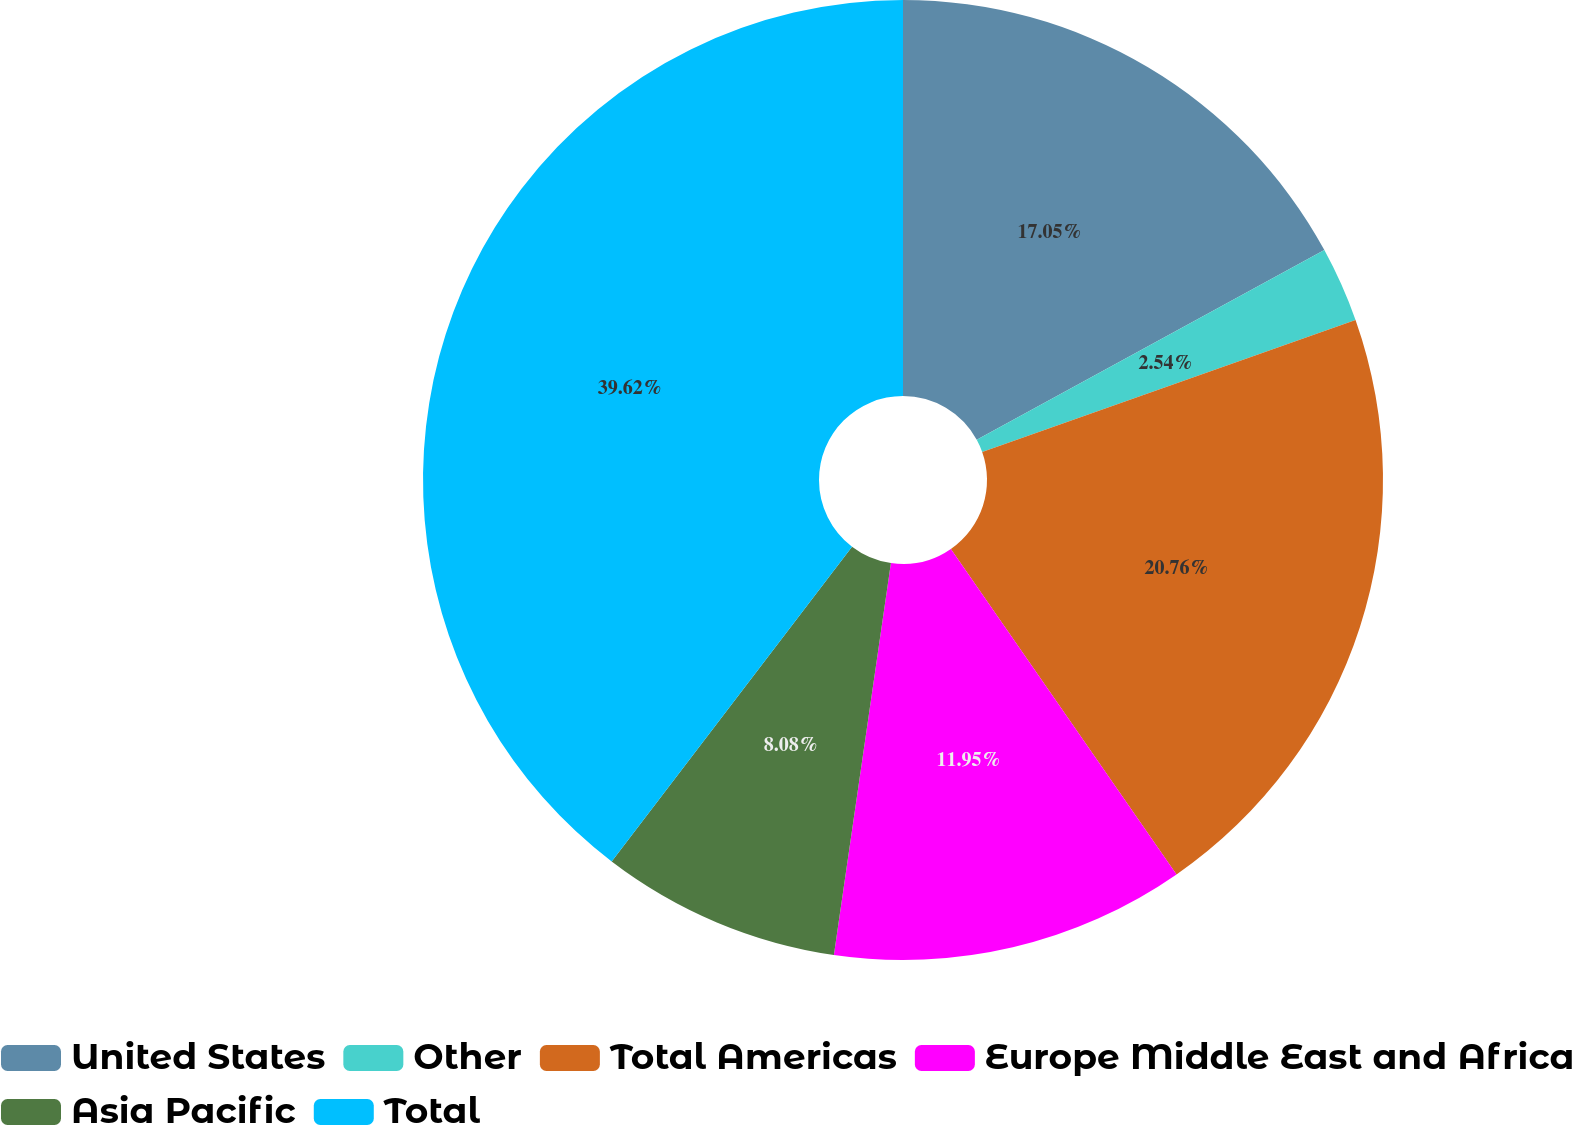Convert chart. <chart><loc_0><loc_0><loc_500><loc_500><pie_chart><fcel>United States<fcel>Other<fcel>Total Americas<fcel>Europe Middle East and Africa<fcel>Asia Pacific<fcel>Total<nl><fcel>17.05%<fcel>2.54%<fcel>20.76%<fcel>11.95%<fcel>8.08%<fcel>39.62%<nl></chart> 